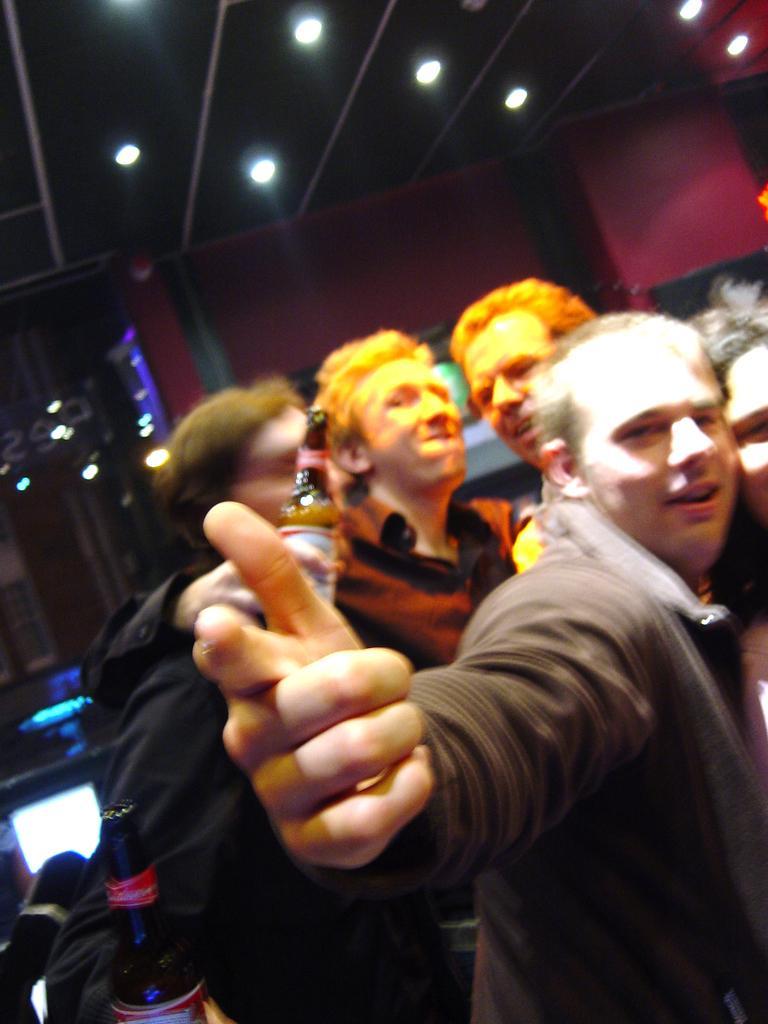How would you summarize this image in a sentence or two? In this image we can see a few people, among them some are holding bottles, at the top of the roof, we can see some lights and poles, in the background we can see a wall. 